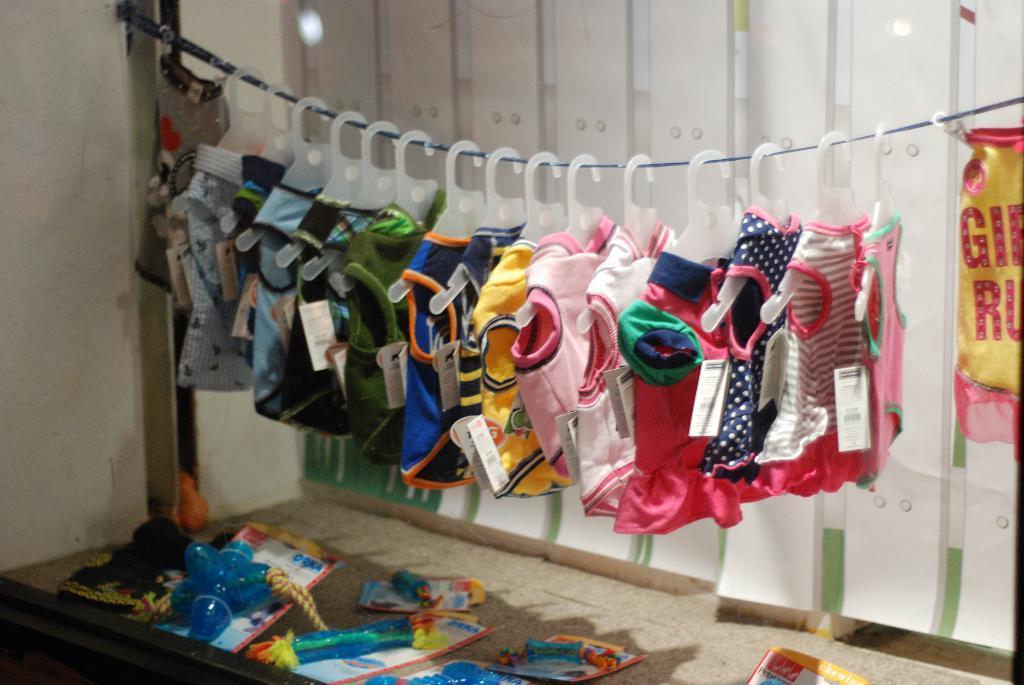Can you describe this image briefly? In this image, we can see clothes with tags are hanging with hangers to the rope. At the bottom of the image, we can see few objects with cards. In the background, we can see wall and sheet. 